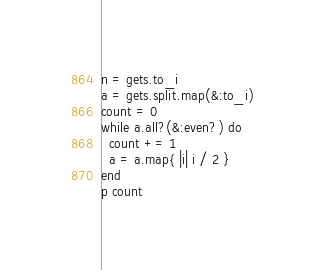Convert code to text. <code><loc_0><loc_0><loc_500><loc_500><_Ruby_>n = gets.to_i
a = gets.split.map(&:to_i)
count = 0
while a.all?(&:even?) do
  count += 1
  a = a.map{ |i| i / 2 }
end
p count</code> 